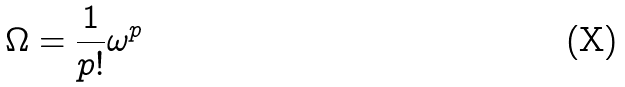<formula> <loc_0><loc_0><loc_500><loc_500>\Omega = \frac { 1 } { p ! } \omega ^ { p }</formula> 